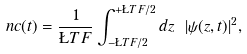Convert formula to latex. <formula><loc_0><loc_0><loc_500><loc_500>\ n c ( t ) = \frac { 1 } { \L T F } \int _ { - \L T F / 2 } ^ { + \L T F / 2 } d z \ | \psi ( z , t ) | ^ { 2 } ,</formula> 